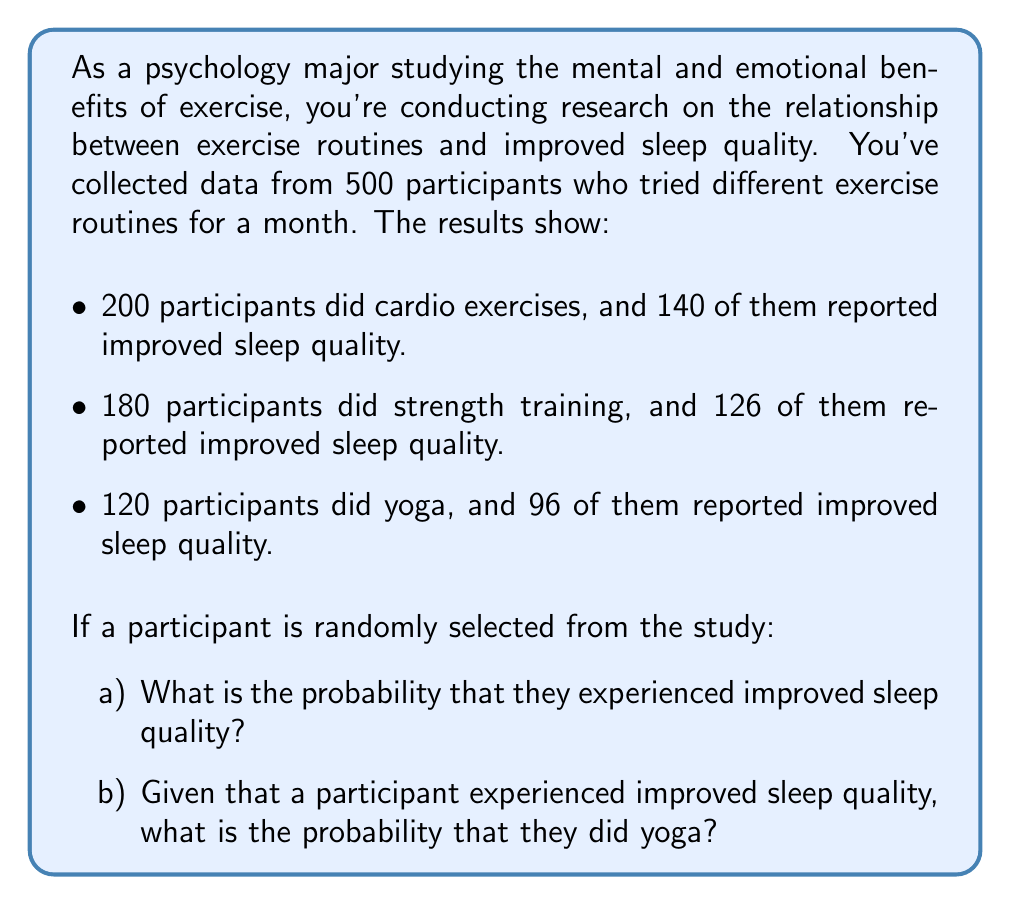Can you solve this math problem? Let's approach this step-by-step:

1) First, let's define our events:
   C: Participant did cardio
   S: Participant did strength training
   Y: Participant did yoga
   I: Participant experienced improved sleep quality

2) We can calculate the following probabilities:

   $P(C) = \frac{200}{500} = 0.4$
   $P(S) = \frac{180}{500} = 0.36$
   $P(Y) = \frac{120}{500} = 0.24$

   $P(I|C) = \frac{140}{200} = 0.7$
   $P(I|S) = \frac{126}{180} = 0.7$
   $P(I|Y) = \frac{96}{120} = 0.8$

3) For part a), we need to calculate $P(I)$. We can use the law of total probability:

   $$P(I) = P(I|C)P(C) + P(I|S)P(S) + P(I|Y)P(Y)$$
   $$P(I) = 0.7 \cdot 0.4 + 0.7 \cdot 0.36 + 0.8 \cdot 0.24$$
   $$P(I) = 0.28 + 0.252 + 0.192 = 0.724$$

4) For part b), we need to calculate $P(Y|I)$. We can use Bayes' theorem:

   $$P(Y|I) = \frac{P(I|Y)P(Y)}{P(I)}$$

   We calculated $P(I)$ in part a), and we know $P(I|Y)$ and $P(Y)$, so:

   $$P(Y|I) = \frac{0.8 \cdot 0.24}{0.724} \approx 0.2651$$
Answer: a) The probability that a randomly selected participant experienced improved sleep quality is 0.724 or 72.4%.

b) Given that a participant experienced improved sleep quality, the probability that they did yoga is approximately 0.2651 or 26.51%. 